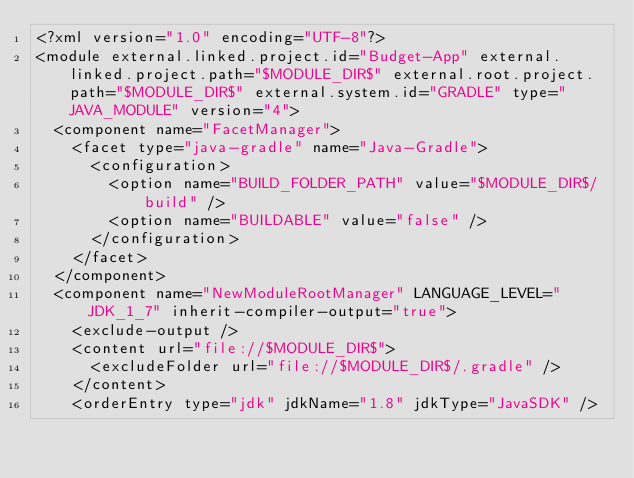<code> <loc_0><loc_0><loc_500><loc_500><_XML_><?xml version="1.0" encoding="UTF-8"?>
<module external.linked.project.id="Budget-App" external.linked.project.path="$MODULE_DIR$" external.root.project.path="$MODULE_DIR$" external.system.id="GRADLE" type="JAVA_MODULE" version="4">
  <component name="FacetManager">
    <facet type="java-gradle" name="Java-Gradle">
      <configuration>
        <option name="BUILD_FOLDER_PATH" value="$MODULE_DIR$/build" />
        <option name="BUILDABLE" value="false" />
      </configuration>
    </facet>
  </component>
  <component name="NewModuleRootManager" LANGUAGE_LEVEL="JDK_1_7" inherit-compiler-output="true">
    <exclude-output />
    <content url="file://$MODULE_DIR$">
      <excludeFolder url="file://$MODULE_DIR$/.gradle" />
    </content>
    <orderEntry type="jdk" jdkName="1.8" jdkType="JavaSDK" /></code> 